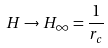Convert formula to latex. <formula><loc_0><loc_0><loc_500><loc_500>H \rightarrow H _ { \infty } = \frac { 1 } { r _ { c } }</formula> 